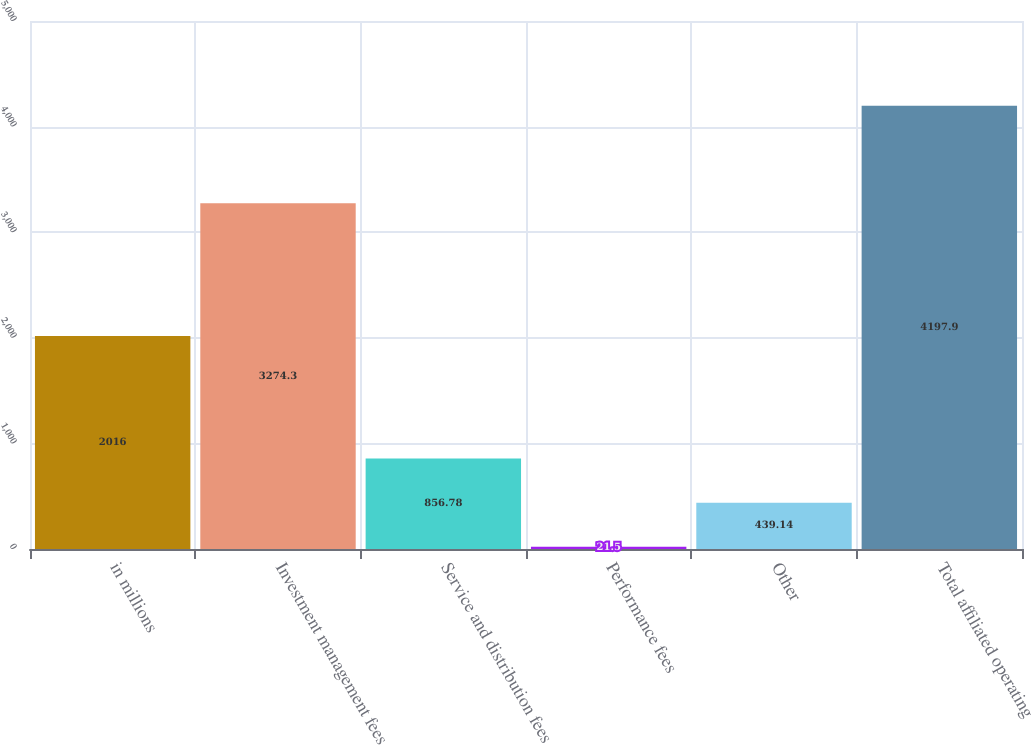<chart> <loc_0><loc_0><loc_500><loc_500><bar_chart><fcel>in millions<fcel>Investment management fees<fcel>Service and distribution fees<fcel>Performance fees<fcel>Other<fcel>Total affiliated operating<nl><fcel>2016<fcel>3274.3<fcel>856.78<fcel>21.5<fcel>439.14<fcel>4197.9<nl></chart> 